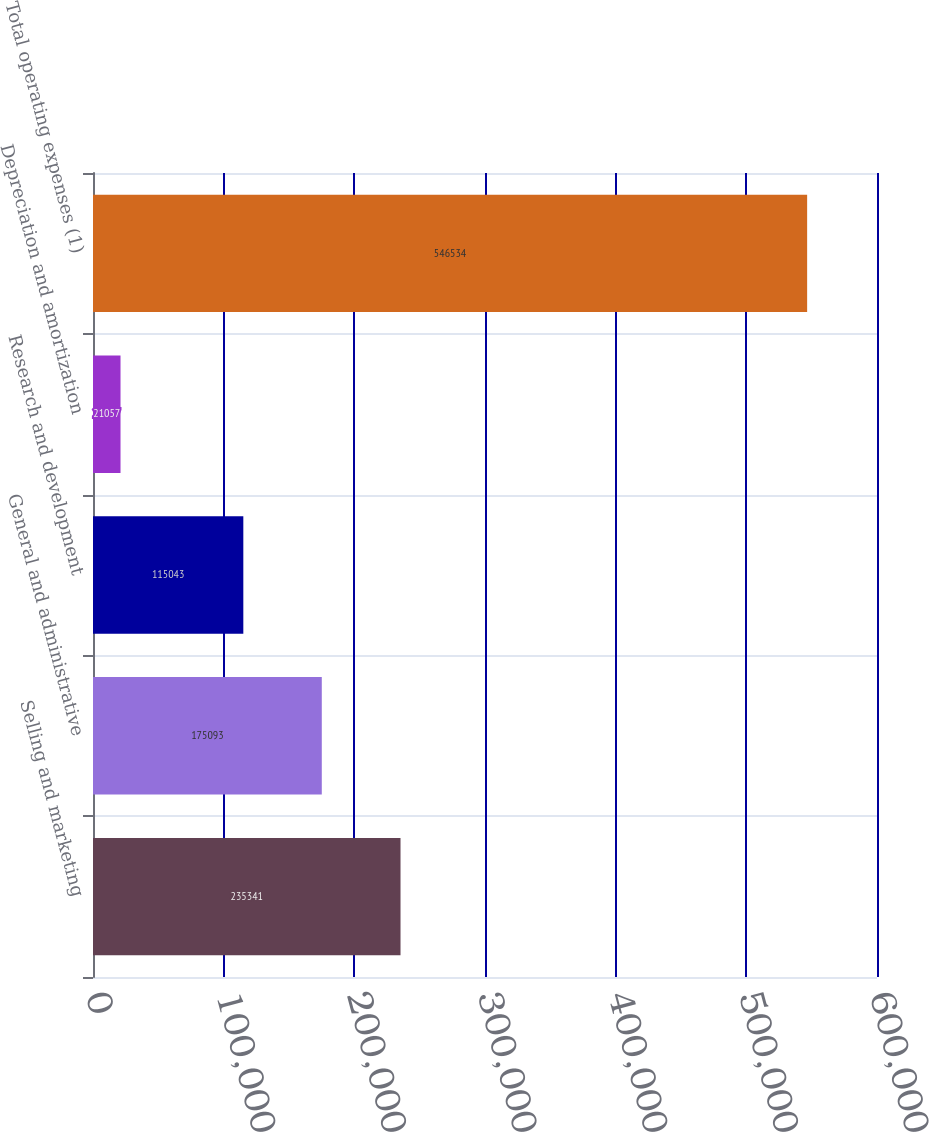Convert chart. <chart><loc_0><loc_0><loc_500><loc_500><bar_chart><fcel>Selling and marketing<fcel>General and administrative<fcel>Research and development<fcel>Depreciation and amortization<fcel>Total operating expenses (1)<nl><fcel>235341<fcel>175093<fcel>115043<fcel>21057<fcel>546534<nl></chart> 